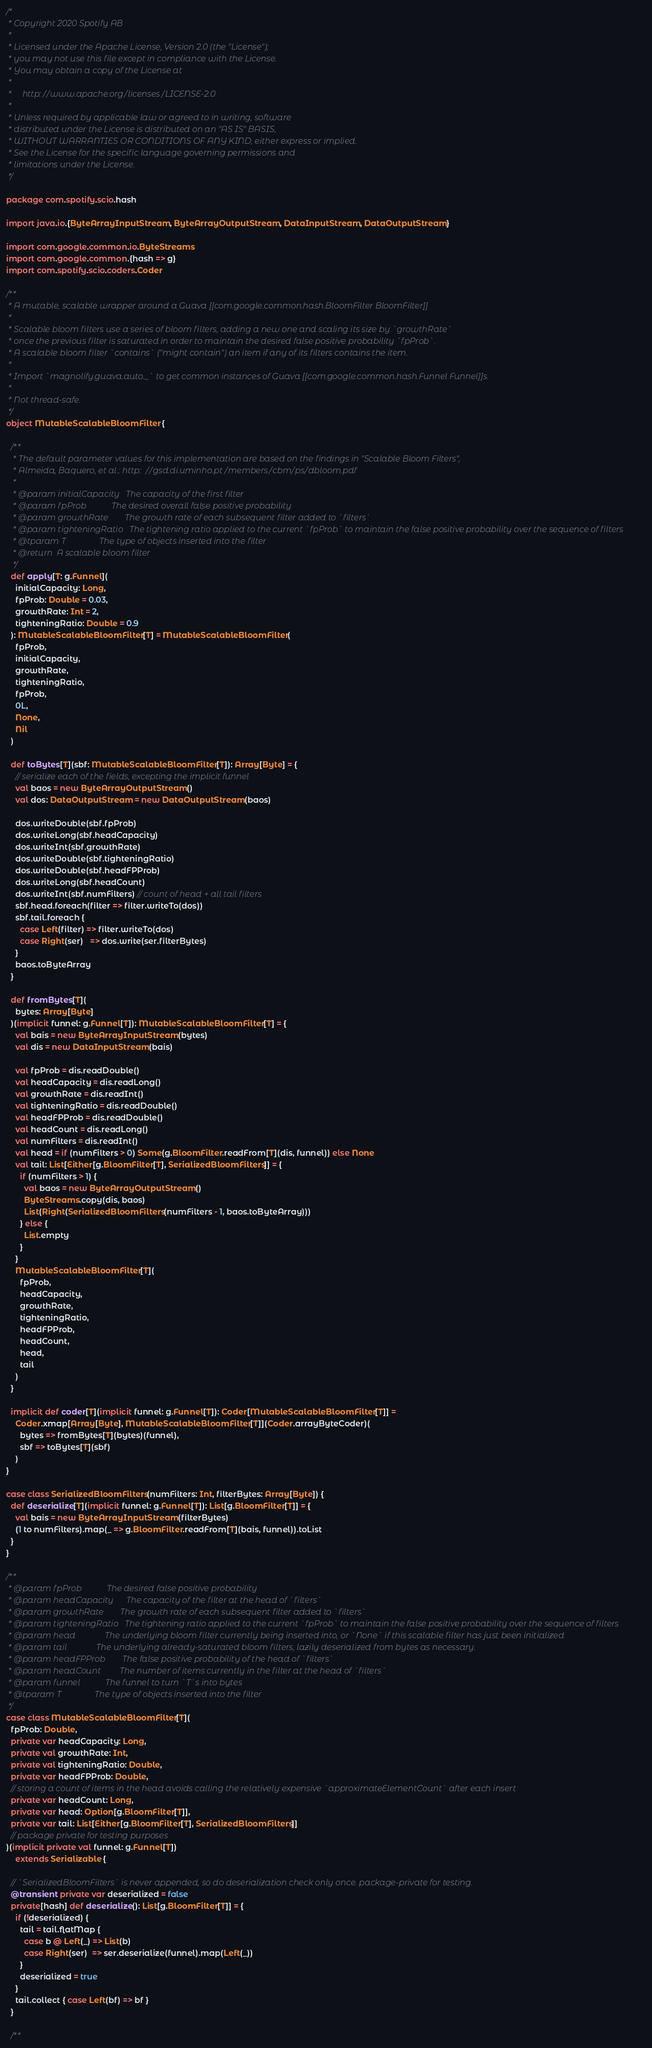<code> <loc_0><loc_0><loc_500><loc_500><_Scala_>/*
 * Copyright 2020 Spotify AB
 *
 * Licensed under the Apache License, Version 2.0 (the "License");
 * you may not use this file except in compliance with the License.
 * You may obtain a copy of the License at
 *
 *     http://www.apache.org/licenses/LICENSE-2.0
 *
 * Unless required by applicable law or agreed to in writing, software
 * distributed under the License is distributed on an "AS IS" BASIS,
 * WITHOUT WARRANTIES OR CONDITIONS OF ANY KIND, either express or implied.
 * See the License for the specific language governing permissions and
 * limitations under the License.
 */

package com.spotify.scio.hash

import java.io.{ByteArrayInputStream, ByteArrayOutputStream, DataInputStream, DataOutputStream}

import com.google.common.io.ByteStreams
import com.google.common.{hash => g}
import com.spotify.scio.coders.Coder

/**
 * A mutable, scalable wrapper around a Guava [[com.google.common.hash.BloomFilter BloomFilter]]
 *
 * Scalable bloom filters use a series of bloom filters, adding a new one and scaling its size by `growthRate`
 * once the previous filter is saturated in order to maintain the desired false positive probability `fpProb`.
 * A scalable bloom filter `contains` ("might contain") an item if any of its filters contains the item.
 *
 * Import `magnolify.guava.auto._` to get common instances of Guava [[com.google.common.hash.Funnel Funnel]]s.
 *
 * Not thread-safe.
 */
object MutableScalableBloomFilter {

  /**
   * The default parameter values for this implementation are based on the findings in "Scalable Bloom Filters",
   * Almeida, Baquero, et al.: http://gsd.di.uminho.pt/members/cbm/ps/dbloom.pdf
   *
   * @param initialCapacity   The capacity of the first filter
   * @param fpProb            The desired overall false positive probability
   * @param growthRate        The growth rate of each subsequent filter added to `filters`
   * @param tighteningRatio   The tightening ratio applied to the current `fpProb` to maintain the false positive probability over the sequence of filters
   * @tparam T                The type of objects inserted into the filter
   * @return  A scalable bloom filter
   */
  def apply[T: g.Funnel](
    initialCapacity: Long,
    fpProb: Double = 0.03,
    growthRate: Int = 2,
    tighteningRatio: Double = 0.9
  ): MutableScalableBloomFilter[T] = MutableScalableBloomFilter(
    fpProb,
    initialCapacity,
    growthRate,
    tighteningRatio,
    fpProb,
    0L,
    None,
    Nil
  )

  def toBytes[T](sbf: MutableScalableBloomFilter[T]): Array[Byte] = {
    // serialize each of the fields, excepting the implicit funnel
    val baos = new ByteArrayOutputStream()
    val dos: DataOutputStream = new DataOutputStream(baos)

    dos.writeDouble(sbf.fpProb)
    dos.writeLong(sbf.headCapacity)
    dos.writeInt(sbf.growthRate)
    dos.writeDouble(sbf.tighteningRatio)
    dos.writeDouble(sbf.headFPProb)
    dos.writeLong(sbf.headCount)
    dos.writeInt(sbf.numFilters) // count of head + all tail filters
    sbf.head.foreach(filter => filter.writeTo(dos))
    sbf.tail.foreach {
      case Left(filter) => filter.writeTo(dos)
      case Right(ser)   => dos.write(ser.filterBytes)
    }
    baos.toByteArray
  }

  def fromBytes[T](
    bytes: Array[Byte]
  )(implicit funnel: g.Funnel[T]): MutableScalableBloomFilter[T] = {
    val bais = new ByteArrayInputStream(bytes)
    val dis = new DataInputStream(bais)

    val fpProb = dis.readDouble()
    val headCapacity = dis.readLong()
    val growthRate = dis.readInt()
    val tighteningRatio = dis.readDouble()
    val headFPProb = dis.readDouble()
    val headCount = dis.readLong()
    val numFilters = dis.readInt()
    val head = if (numFilters > 0) Some(g.BloomFilter.readFrom[T](dis, funnel)) else None
    val tail: List[Either[g.BloomFilter[T], SerializedBloomFilters]] = {
      if (numFilters > 1) {
        val baos = new ByteArrayOutputStream()
        ByteStreams.copy(dis, baos)
        List(Right(SerializedBloomFilters(numFilters - 1, baos.toByteArray)))
      } else {
        List.empty
      }
    }
    MutableScalableBloomFilter[T](
      fpProb,
      headCapacity,
      growthRate,
      tighteningRatio,
      headFPProb,
      headCount,
      head,
      tail
    )
  }

  implicit def coder[T](implicit funnel: g.Funnel[T]): Coder[MutableScalableBloomFilter[T]] =
    Coder.xmap[Array[Byte], MutableScalableBloomFilter[T]](Coder.arrayByteCoder)(
      bytes => fromBytes[T](bytes)(funnel),
      sbf => toBytes[T](sbf)
    )
}

case class SerializedBloomFilters(numFilters: Int, filterBytes: Array[Byte]) {
  def deserialize[T](implicit funnel: g.Funnel[T]): List[g.BloomFilter[T]] = {
    val bais = new ByteArrayInputStream(filterBytes)
    (1 to numFilters).map(_ => g.BloomFilter.readFrom[T](bais, funnel)).toList
  }
}

/**
 * @param fpProb            The desired false positive probability
 * @param headCapacity      The capacity of the filter at the head of `filters`
 * @param growthRate        The growth rate of each subsequent filter added to `filters`
 * @param tighteningRatio   The tightening ratio applied to the current `fpProb` to maintain the false positive probability over the sequence of filters
 * @param head              The underlying bloom filter currently being inserted into, or `None` if this scalable filter has just been initialized
 * @param tail              The underlying already-saturated bloom filters, lazily deserialized from bytes as necessary.
 * @param headFPProb        The false positive probability of the head of `filters`
 * @param headCount         The number of items currently in the filter at the head of `filters`
 * @param funnel            The funnel to turn `T`s into bytes
 * @tparam T                The type of objects inserted into the filter
 */
case class MutableScalableBloomFilter[T](
  fpProb: Double,
  private var headCapacity: Long,
  private val growthRate: Int,
  private val tighteningRatio: Double,
  private var headFPProb: Double,
  // storing a count of items in the head avoids calling the relatively expensive `approximateElementCount` after each insert
  private var headCount: Long,
  private var head: Option[g.BloomFilter[T]],
  private var tail: List[Either[g.BloomFilter[T], SerializedBloomFilters]]
  // package private for testing purposes
)(implicit private val funnel: g.Funnel[T])
    extends Serializable {

  // `SerializedBloomFilters` is never appended, so do deserialization check only once. package-private for testing.
  @transient private var deserialized = false
  private[hash] def deserialize(): List[g.BloomFilter[T]] = {
    if (!deserialized) {
      tail = tail.flatMap {
        case b @ Left(_) => List(b)
        case Right(ser)  => ser.deserialize(funnel).map(Left(_))
      }
      deserialized = true
    }
    tail.collect { case Left(bf) => bf }
  }

  /**</code> 